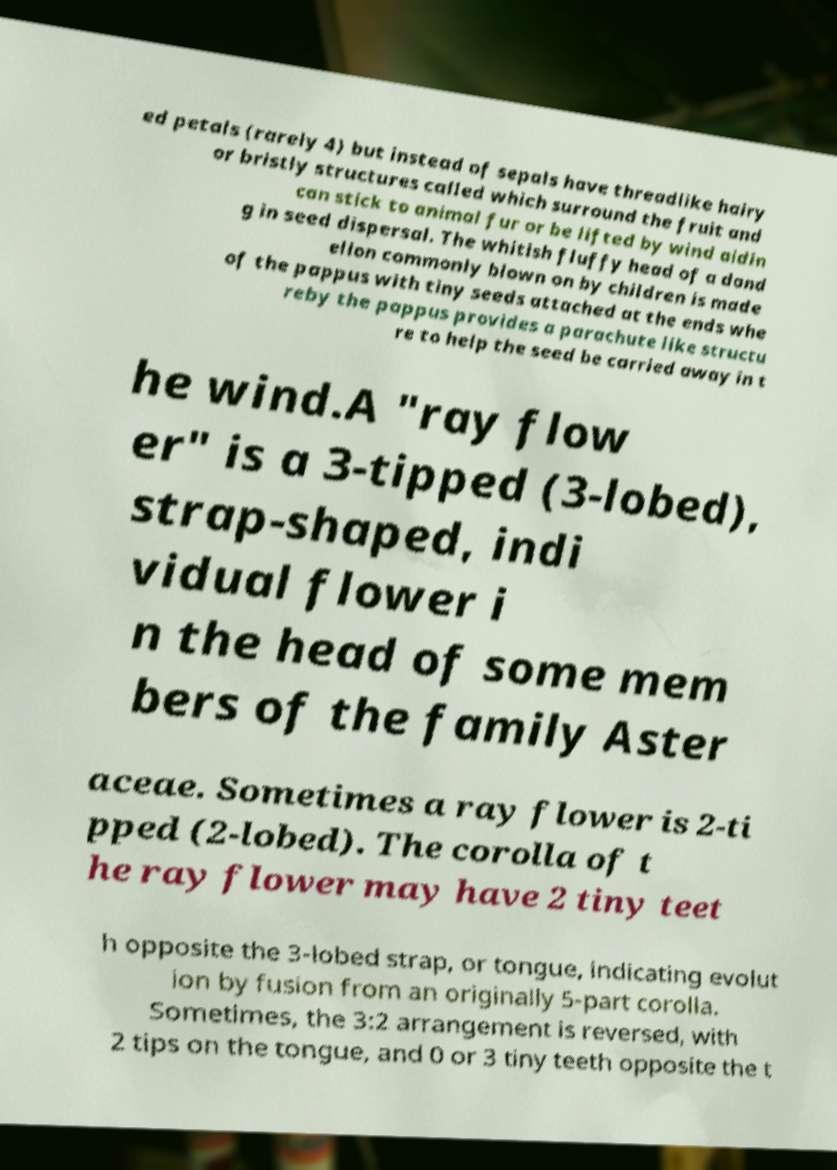Please identify and transcribe the text found in this image. ed petals (rarely 4) but instead of sepals have threadlike hairy or bristly structures called which surround the fruit and can stick to animal fur or be lifted by wind aidin g in seed dispersal. The whitish fluffy head of a dand elion commonly blown on by children is made of the pappus with tiny seeds attached at the ends whe reby the pappus provides a parachute like structu re to help the seed be carried away in t he wind.A "ray flow er" is a 3-tipped (3-lobed), strap-shaped, indi vidual flower i n the head of some mem bers of the family Aster aceae. Sometimes a ray flower is 2-ti pped (2-lobed). The corolla of t he ray flower may have 2 tiny teet h opposite the 3-lobed strap, or tongue, indicating evolut ion by fusion from an originally 5-part corolla. Sometimes, the 3:2 arrangement is reversed, with 2 tips on the tongue, and 0 or 3 tiny teeth opposite the t 